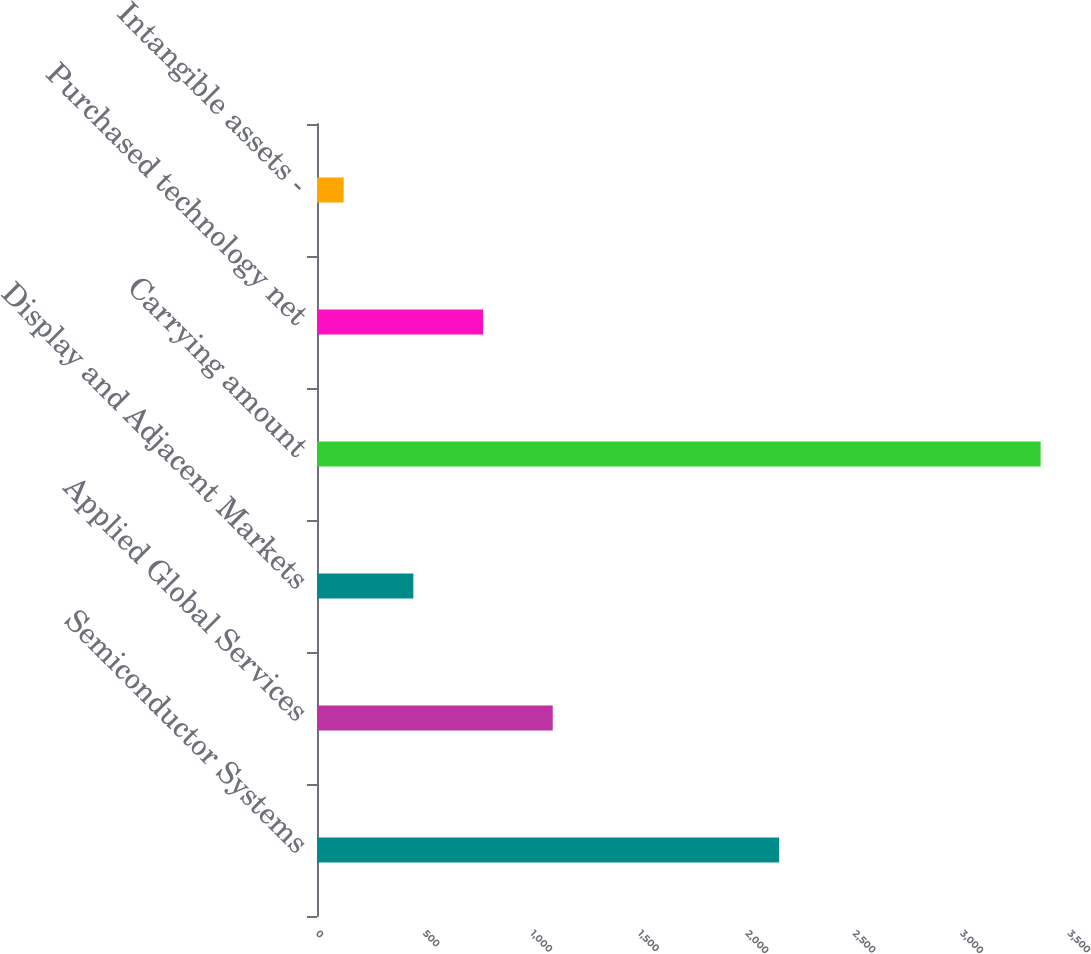Convert chart to OTSL. <chart><loc_0><loc_0><loc_500><loc_500><bar_chart><fcel>Semiconductor Systems<fcel>Applied Global Services<fcel>Display and Adjacent Markets<fcel>Carrying amount<fcel>Purchased technology net<fcel>Intangible assets -<nl><fcel>2151<fcel>1097.2<fcel>448.4<fcel>3368<fcel>772.8<fcel>124<nl></chart> 